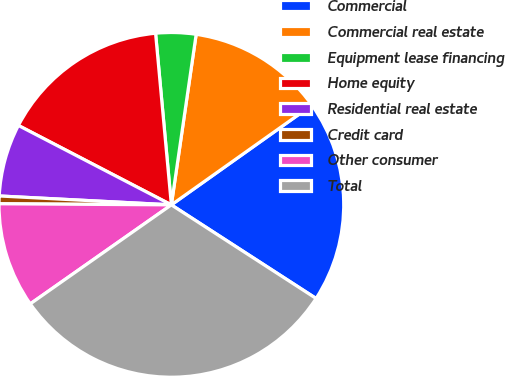Convert chart to OTSL. <chart><loc_0><loc_0><loc_500><loc_500><pie_chart><fcel>Commercial<fcel>Commercial real estate<fcel>Equipment lease financing<fcel>Home equity<fcel>Residential real estate<fcel>Credit card<fcel>Other consumer<fcel>Total<nl><fcel>18.96%<fcel>12.88%<fcel>3.76%<fcel>15.92%<fcel>6.8%<fcel>0.72%<fcel>9.84%<fcel>31.13%<nl></chart> 